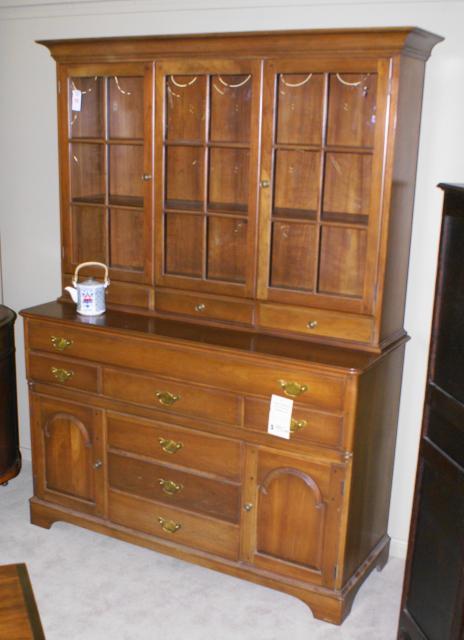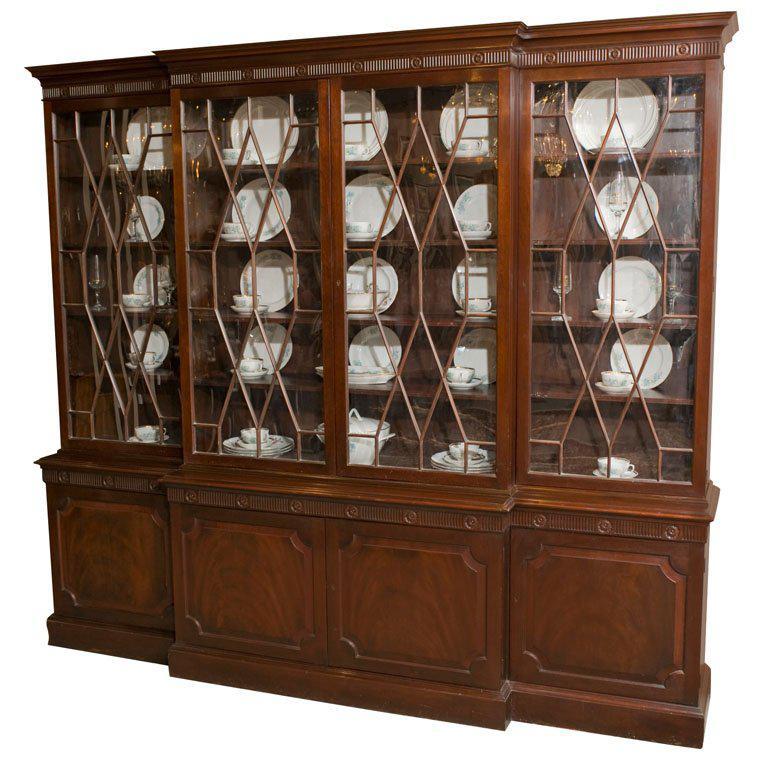The first image is the image on the left, the second image is the image on the right. Given the left and right images, does the statement "The shelves on the left are full." hold true? Answer yes or no. No. 